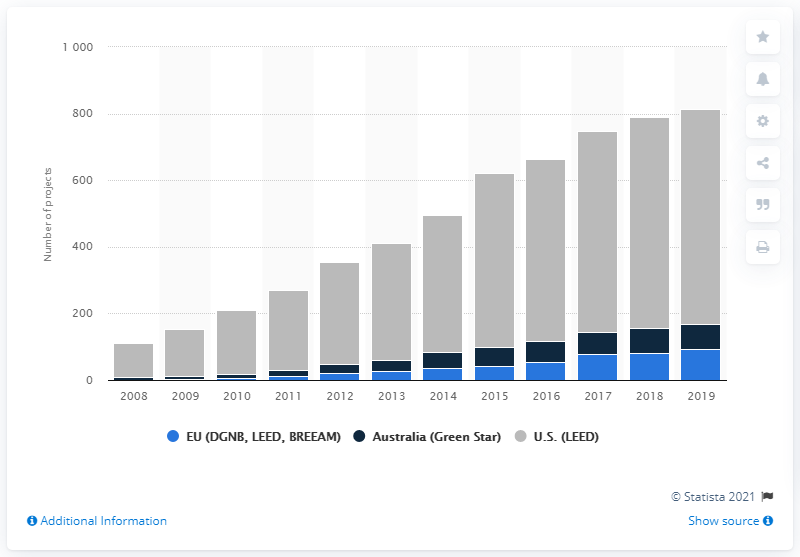Specify some key components in this picture. In 2019, a total of 647 green building certified projects were completed by Hochtief in the United States. 